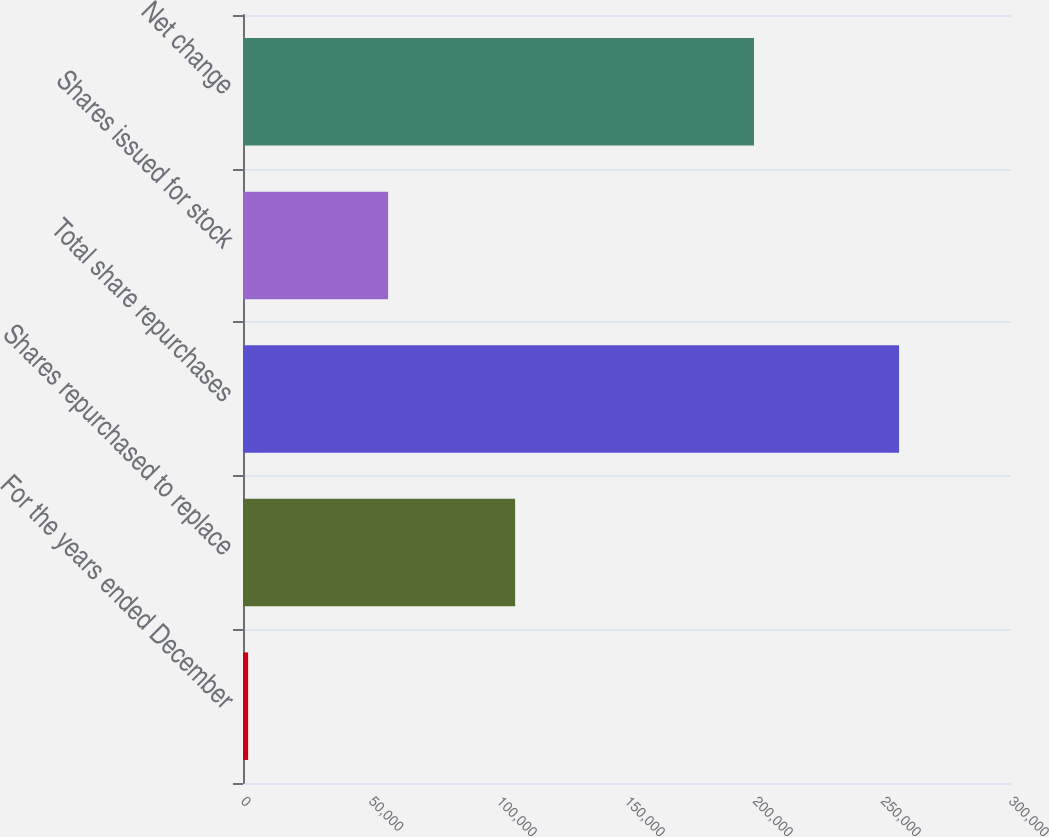<chart> <loc_0><loc_0><loc_500><loc_500><bar_chart><fcel>For the years ended December<fcel>Shares repurchased to replace<fcel>Total share repurchases<fcel>Shares issued for stock<fcel>Net change<nl><fcel>2007<fcel>106302<fcel>256285<fcel>56670<fcel>199615<nl></chart> 